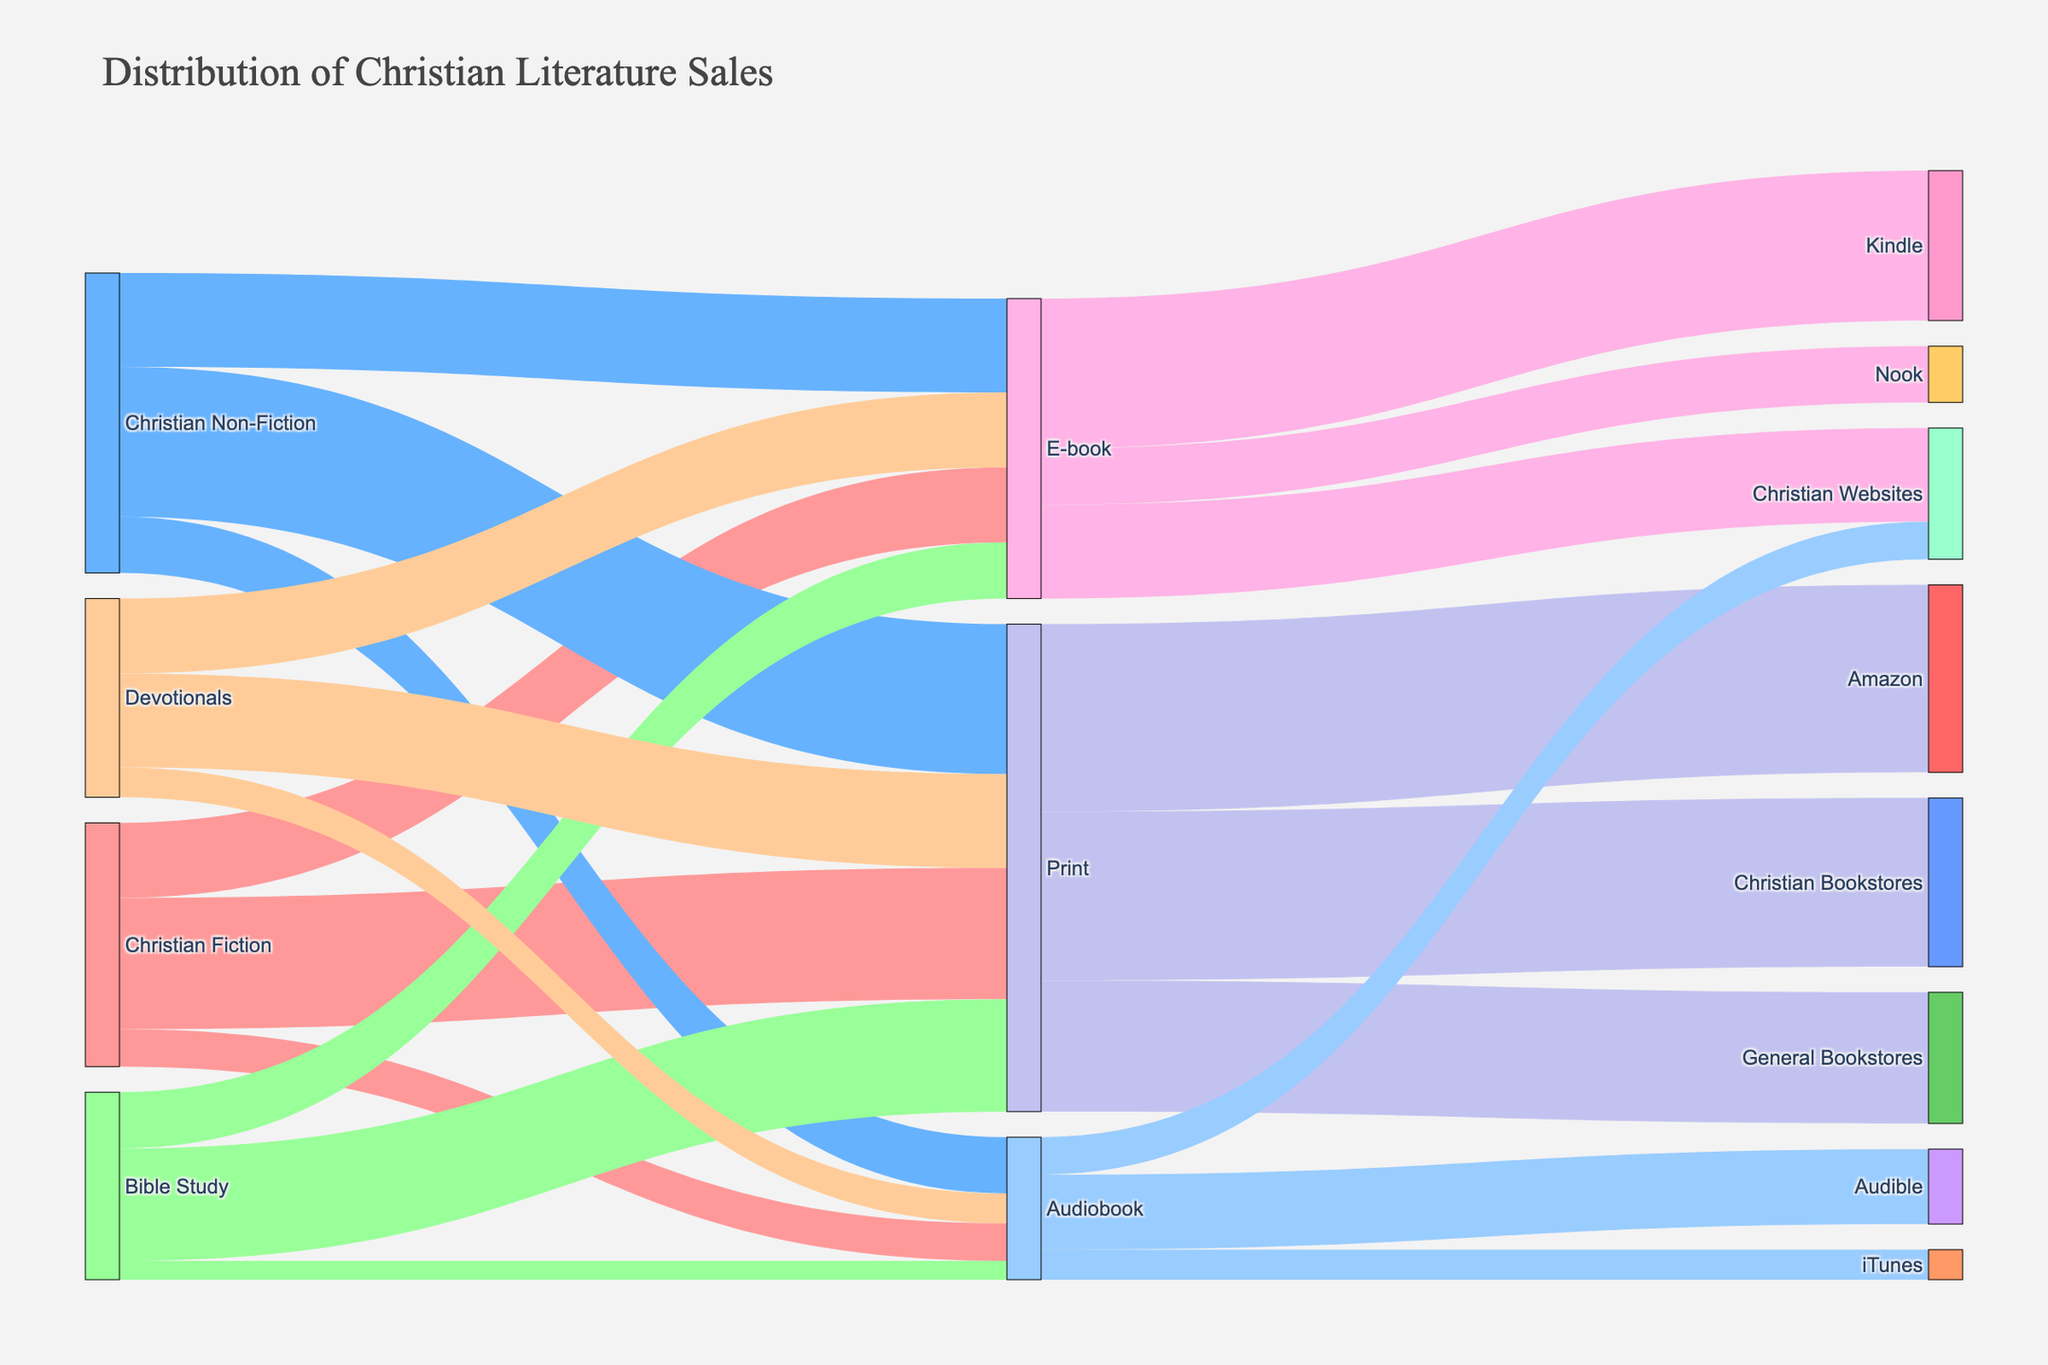What's the title of the figure? The title of the figure is usually displayed prominently at the top of the plot. Read the title text.
Answer: Distribution of Christian Literature Sales Which genre has the highest sales in print format? Find the nodes corresponding to different genres and follow the links leading to the 'Print' node. Compare the values of these links. Christian Non-Fiction has the highest sales in print format with a value of 40.
Answer: Christian Non-Fiction What is the total number of sales for E-books across all genres? Sum the values of all links leading to the 'E-book' node from different genres. The values are 20 (Christian Fiction) + 25 (Christian Non-Fiction) + 15 (Bible Study) + 20 (Devotionals), which sum up to 80.
Answer: 80 How do the sales of Audiobooks for Bible Study compare to those for Devotionals? Locate the values of the sales for Bible Study and Devotionals leading to the 'Audiobook' node and compare them. Bible Study has an Audiobook sale of 5, while Devotionals have 8.
Answer: Devotionals has more Audiobook sales than Bible Study Through which platform is the majority of Print sales distributed? Follow the links from the 'Print' node to the various platforms and compare the values. Amazon receives the highest, with 50 sales.
Answer: Amazon What is the total number of sales across all genres and platforms? Sum all the values in the dataset to get the total number of sales. Adding values: 35 + 20 + 10 + 40 + 25 + 15 + 30 + 15 + 5 + 25 + 20 + 8 + 50 + 45 + 35 + 40 + 15 + 25 + 20 + 10 + 8. This equals 451.
Answer: 451 What percentage of Print sales are through Christian Bookstores? Find the value of Print sales through Christian Bookstores and divide it by the total Print sales, then multiply by 100 for percentage. Christian Bookstores have 45 Print sales. Total Print sales are 50 (Amazon) + 45 (Christian Bookstores) + 35 (General Bookstores) = 130. So, (45/130) * 100 ≈ 34.62%.
Answer: 34.62% What is the combined sales of Christian Fiction in E-books and Audiobooks? Sum the E-book and Audiobook sales for Christian Fiction. These are 20 (E-book) + 10 (Audiobook) = 30.
Answer: 30 Which genre has the least sales in Audiobook format? Compare the values linked to the 'Audiobook' node from different genres. Bible Study has the least Audiobook sales with a value of 5.
Answer: Bible Study Which genre contributes the most to Kindle sales? Follow the links from different genres to 'E-book' and then to 'Kindle'. Christian Non-Fiction contributes the most, as it has the highest E-book sales (25) and Kindle is the major platform for E-books.
Answer: Christian Non-Fiction 